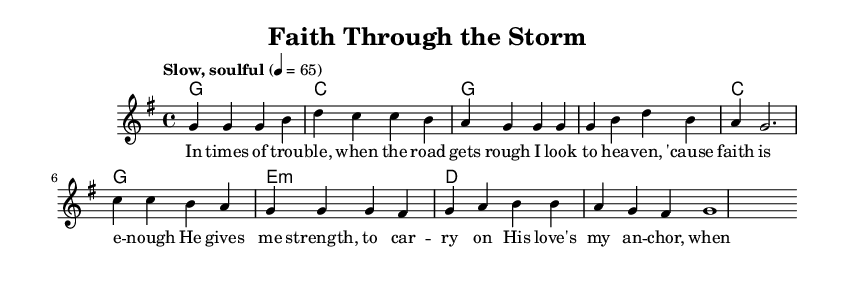What is the key signature of this music? The key signature is G major, which has one sharp (F#). This can be identified from the 'g' in the \key section of the embedded code and is confirmed by the context of the melody indicating the notes that fit within this scale.
Answer: G major What is the time signature of this music? The time signature is 4/4, which is indicated in the \time section of the code. This means there are four beats in each measure, and each quarter note gets one beat.
Answer: 4/4 What is the tempo marking for this music? The tempo marking is "Slow, soulful" set to 65 beats per minute. This is specified in the \tempo section of the embedded code, advising how the piece should be played.
Answer: Slow, soulful How many measures are in the chorus section? The chorus section consists of four measures. This can be determined by counting the number of groups of notes presented in the section corresponding to the chorus in the melody part.
Answer: 4 What key change occurs in the harmony before the final measure? The harmony shifts to E minor before the final measure. This is revealed by looking at the 'e:m' in the harmony section that indicates a minor chord for E, just before the last chord which is a G major.
Answer: E minor What are the themes explored in the lyrics? The themes explored are faith and hope during difficult times. Analyzing the lyrics reveals a focus on looking to heaven for strength and love as an anchor amidst trouble, aligning with the gospel-influenced blues genre.
Answer: Faith and hope 